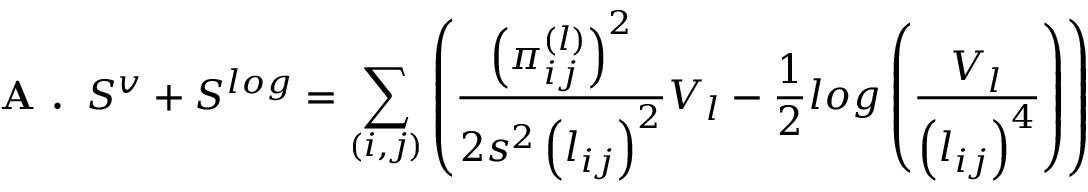Convert formula to latex. <formula><loc_0><loc_0><loc_500><loc_500>A . \, S ^ { v } + S ^ { \log } = \sum _ { ( i , j ) } \left ( \frac { \left ( \pi _ { i j } ^ { ( l ) } \right ) ^ { 2 } } { 2 s ^ { 2 } \left ( l _ { i j } \right ) ^ { 2 } } V _ { l } - \frac { 1 } { 2 } \log \left ( \frac { V _ { l } } { \left ( l _ { i j } \right ) ^ { 4 } } \right ) \right )</formula> 